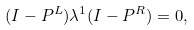<formula> <loc_0><loc_0><loc_500><loc_500>( I - P ^ { L } ) \lambda ^ { 1 } ( I - P ^ { R } ) = 0 ,</formula> 